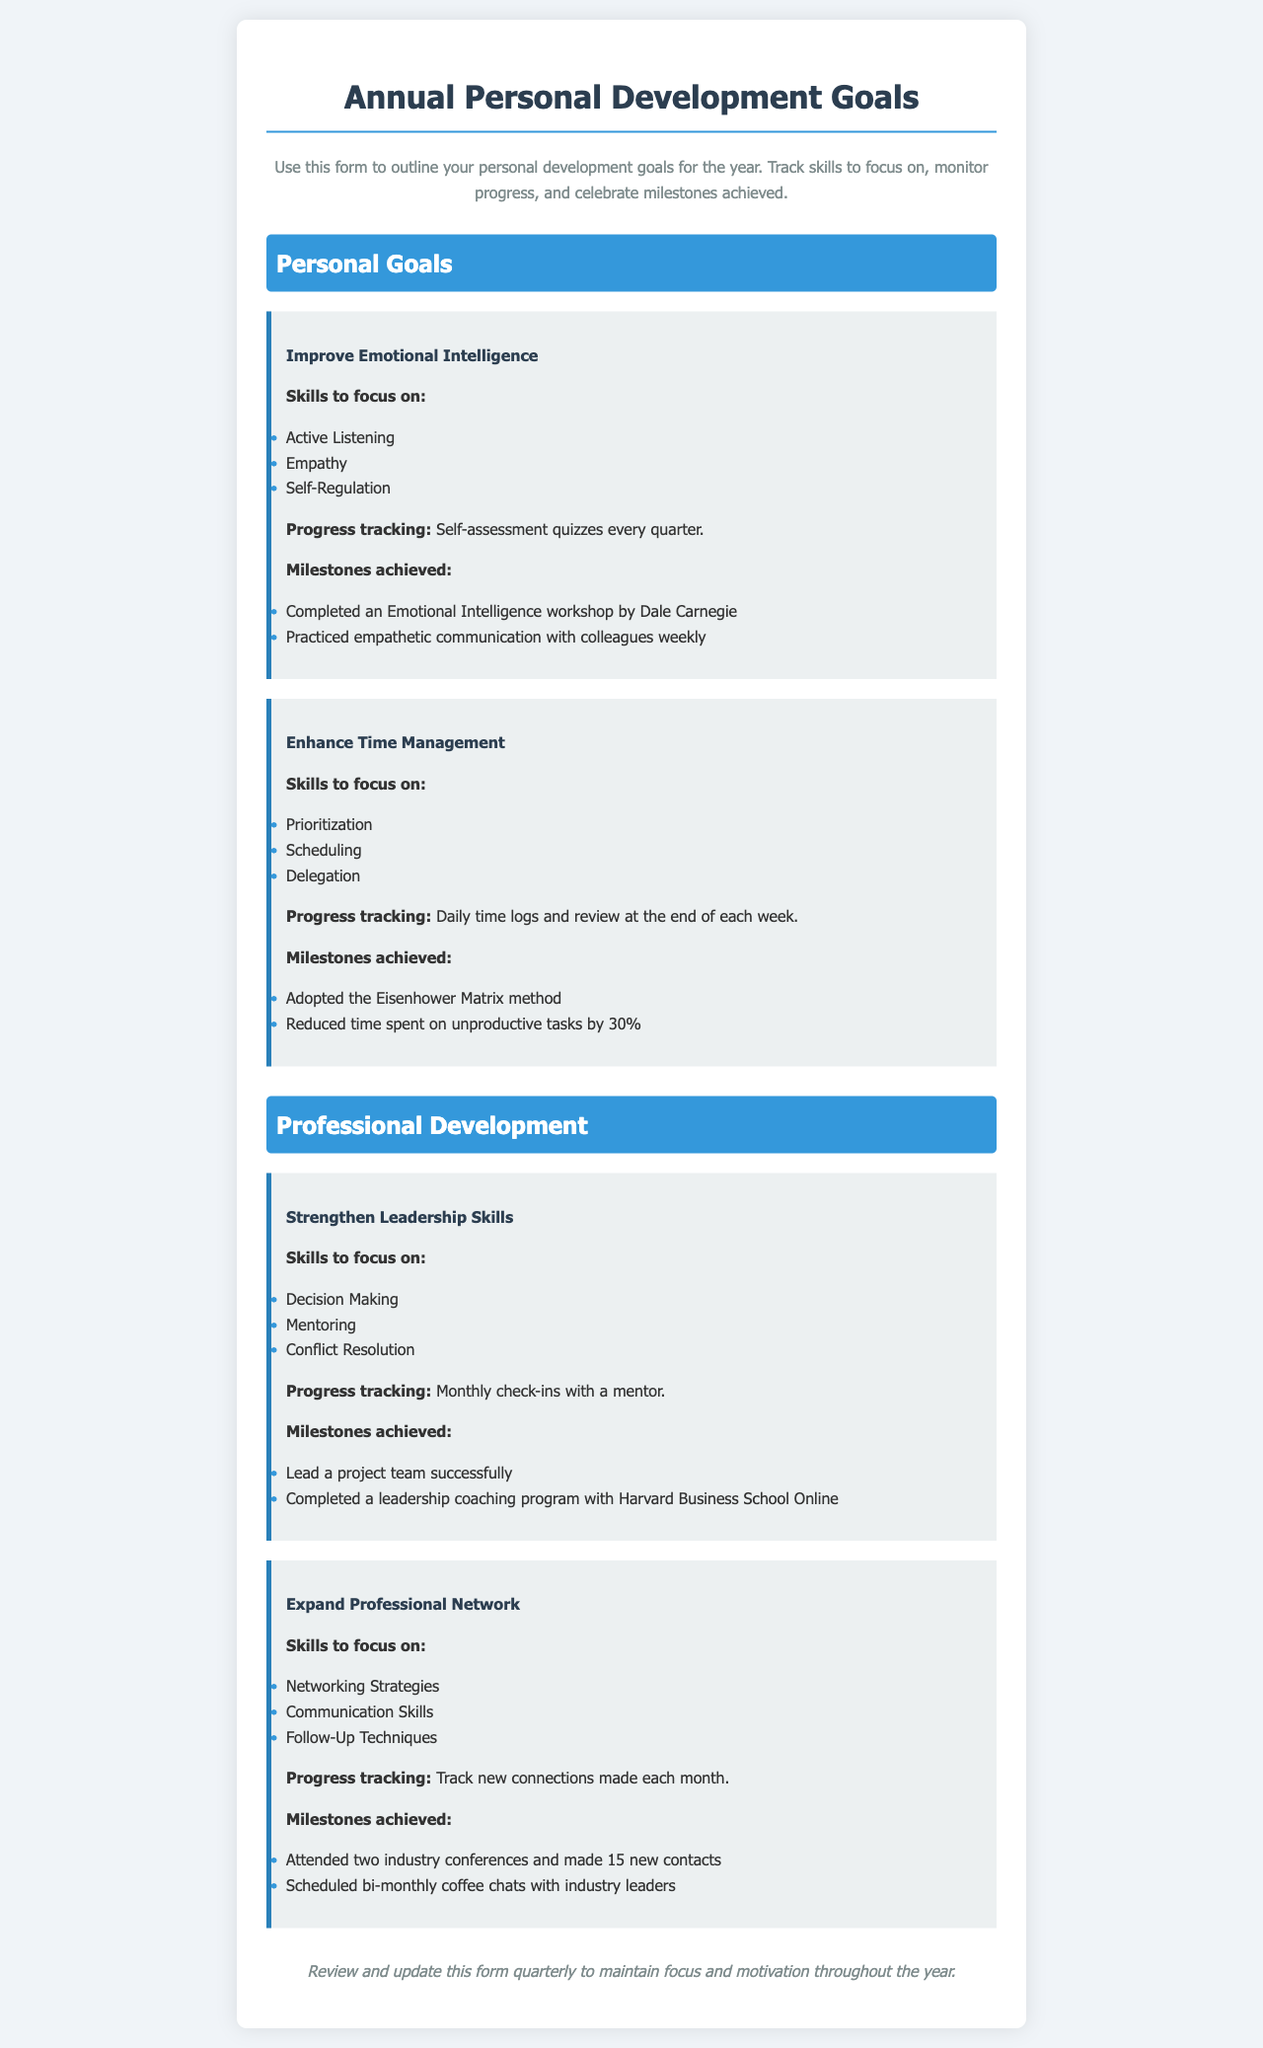What is the title of the document? The title is provided at the top of the document in a prominent header format.
Answer: Annual Personal Development Goals How many personal goals are listed in the document? The count of listed personal goals can be found by reviewing the Personal Goals section.
Answer: 2 What skill is focused on in the goal to improve emotional intelligence? Each goal includes specific skills to focus on, one of which can be identified from the Emotional Intelligence goal.
Answer: Active Listening What method was adopted to enhance time management? The document describes techniques or methods related to each goal, which includes the method for time management.
Answer: Eisenhower Matrix How often are progress tracking assessments for emotional intelligence conducted? The frequency of assessments is mentioned in the progress tracking section of the Emotional Intelligence goal.
Answer: Every quarter Which program was completed for strengthening leadership skills? The document lists milestones achieved under each goal, including successful completion of programs.
Answer: Leadership coaching program with Harvard Business School Online What is the main focus of the goal to expand professional network? The skills to focus on are specified under each goal, indicating the main focus for expanding the network.
Answer: Networking Strategies What percentage was reduced in time spent on unproductive tasks? The milestone achieved section under the time management goal indicates the numeric reduction in time spent.
Answer: 30% 